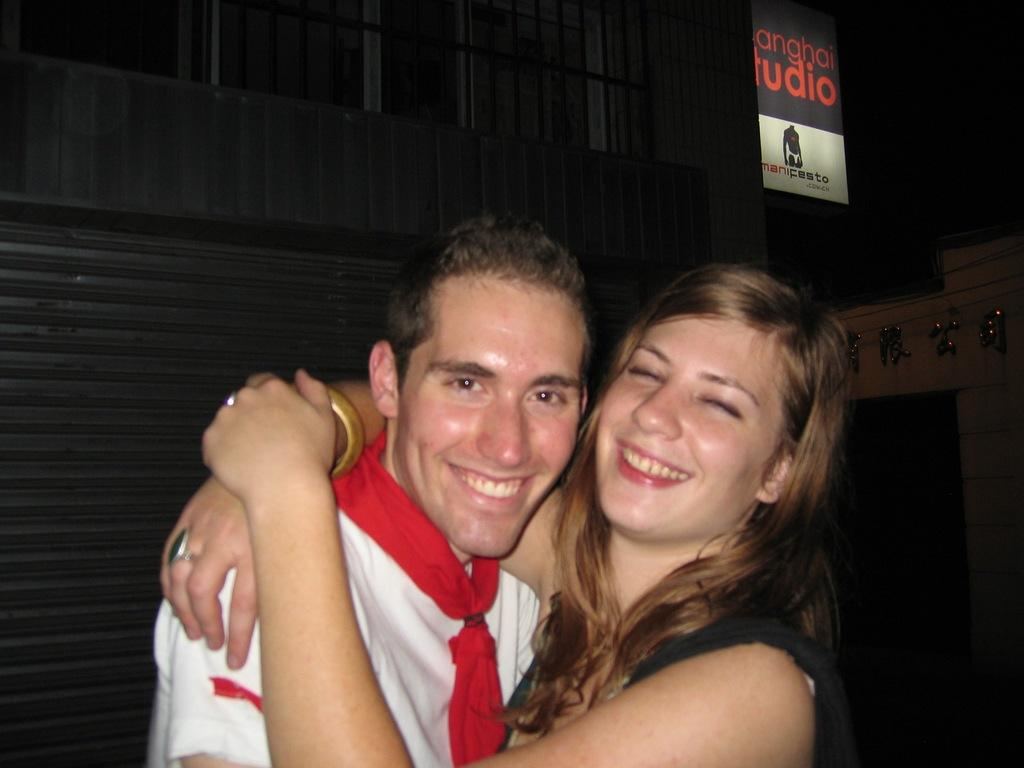How many people are in the image? There are two persons in the image. What are the persons wearing? The persons are wearing clothes. What are the persons doing in the image? The persons are hugging each other. What can be seen in the top right of the image? There is a board in the top right of the image. What color is the orange on the shelf in the image? There is no orange or shelf present in the image. 